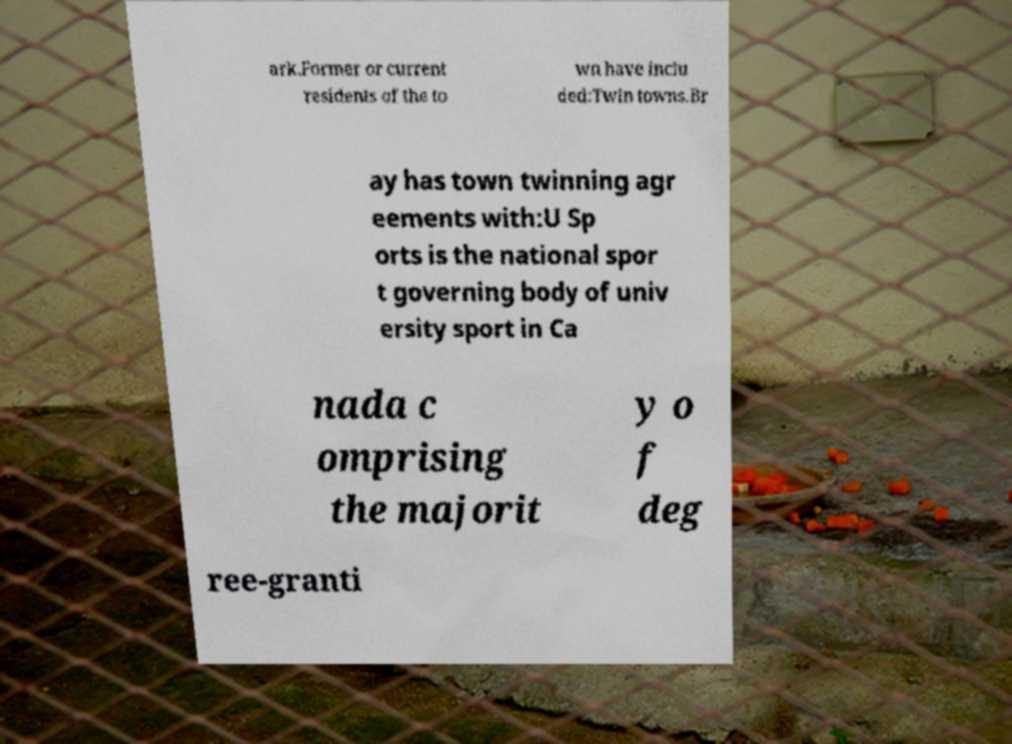Can you accurately transcribe the text from the provided image for me? ark.Former or current residents of the to wn have inclu ded:Twin towns.Br ay has town twinning agr eements with:U Sp orts is the national spor t governing body of univ ersity sport in Ca nada c omprising the majorit y o f deg ree-granti 